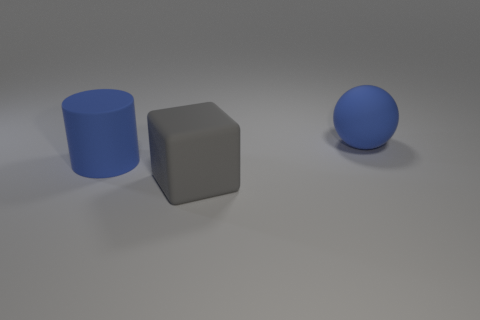What can you infer about the setting from this image? The setting appears to be a simple, unadorned space with a neutral background. There's no context to suggest a specific location, indicating that the focus is solely on the objects and their characteristics. 